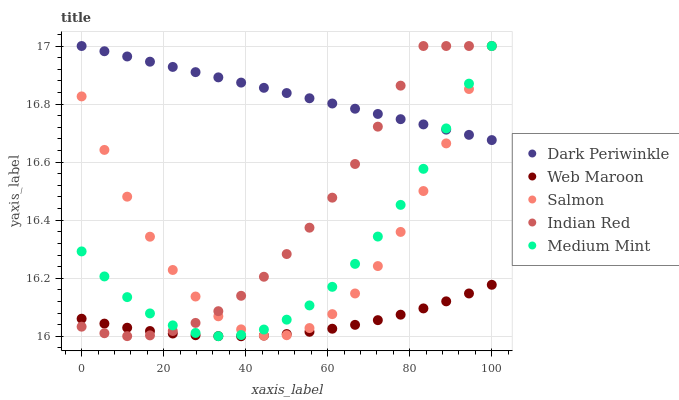Does Web Maroon have the minimum area under the curve?
Answer yes or no. Yes. Does Dark Periwinkle have the maximum area under the curve?
Answer yes or no. Yes. Does Salmon have the minimum area under the curve?
Answer yes or no. No. Does Salmon have the maximum area under the curve?
Answer yes or no. No. Is Dark Periwinkle the smoothest?
Answer yes or no. Yes. Is Salmon the roughest?
Answer yes or no. Yes. Is Web Maroon the smoothest?
Answer yes or no. No. Is Web Maroon the roughest?
Answer yes or no. No. Does Web Maroon have the lowest value?
Answer yes or no. Yes. Does Salmon have the lowest value?
Answer yes or no. No. Does Indian Red have the highest value?
Answer yes or no. Yes. Does Web Maroon have the highest value?
Answer yes or no. No. Is Web Maroon less than Dark Periwinkle?
Answer yes or no. Yes. Is Dark Periwinkle greater than Web Maroon?
Answer yes or no. Yes. Does Indian Red intersect Web Maroon?
Answer yes or no. Yes. Is Indian Red less than Web Maroon?
Answer yes or no. No. Is Indian Red greater than Web Maroon?
Answer yes or no. No. Does Web Maroon intersect Dark Periwinkle?
Answer yes or no. No. 